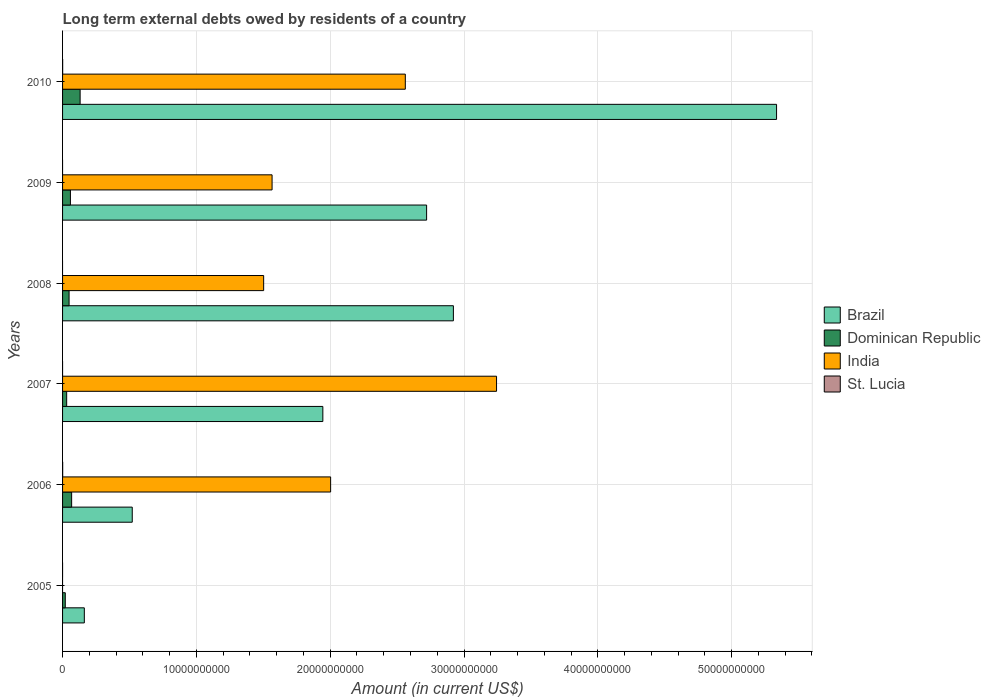How many different coloured bars are there?
Your response must be concise. 4. Are the number of bars per tick equal to the number of legend labels?
Provide a short and direct response. No. Are the number of bars on each tick of the Y-axis equal?
Make the answer very short. No. How many bars are there on the 6th tick from the top?
Provide a short and direct response. 2. What is the amount of long-term external debts owed by residents in Dominican Republic in 2006?
Provide a succinct answer. 6.78e+08. Across all years, what is the maximum amount of long-term external debts owed by residents in Brazil?
Give a very brief answer. 5.34e+1. Across all years, what is the minimum amount of long-term external debts owed by residents in India?
Offer a very short reply. 0. In which year was the amount of long-term external debts owed by residents in St. Lucia maximum?
Your answer should be compact. 2006. What is the total amount of long-term external debts owed by residents in India in the graph?
Provide a succinct answer. 1.09e+11. What is the difference between the amount of long-term external debts owed by residents in Brazil in 2006 and that in 2008?
Keep it short and to the point. -2.40e+1. What is the difference between the amount of long-term external debts owed by residents in India in 2009 and the amount of long-term external debts owed by residents in Brazil in 2008?
Offer a very short reply. -1.35e+1. What is the average amount of long-term external debts owed by residents in Brazil per year?
Make the answer very short. 2.27e+1. In the year 2010, what is the difference between the amount of long-term external debts owed by residents in India and amount of long-term external debts owed by residents in St. Lucia?
Your answer should be very brief. 2.56e+1. In how many years, is the amount of long-term external debts owed by residents in Dominican Republic greater than 40000000000 US$?
Your response must be concise. 0. What is the ratio of the amount of long-term external debts owed by residents in Brazil in 2007 to that in 2009?
Make the answer very short. 0.71. Is the amount of long-term external debts owed by residents in Brazil in 2009 less than that in 2010?
Provide a short and direct response. Yes. What is the difference between the highest and the second highest amount of long-term external debts owed by residents in Brazil?
Make the answer very short. 2.41e+1. What is the difference between the highest and the lowest amount of long-term external debts owed by residents in India?
Give a very brief answer. 3.24e+1. Is the sum of the amount of long-term external debts owed by residents in Dominican Republic in 2009 and 2010 greater than the maximum amount of long-term external debts owed by residents in Brazil across all years?
Keep it short and to the point. No. Is it the case that in every year, the sum of the amount of long-term external debts owed by residents in St. Lucia and amount of long-term external debts owed by residents in India is greater than the amount of long-term external debts owed by residents in Dominican Republic?
Your answer should be compact. No. How many bars are there?
Offer a very short reply. 19. How many years are there in the graph?
Keep it short and to the point. 6. What is the difference between two consecutive major ticks on the X-axis?
Offer a terse response. 1.00e+1. Are the values on the major ticks of X-axis written in scientific E-notation?
Provide a succinct answer. No. Does the graph contain grids?
Give a very brief answer. Yes. How many legend labels are there?
Ensure brevity in your answer.  4. What is the title of the graph?
Ensure brevity in your answer.  Long term external debts owed by residents of a country. Does "Kuwait" appear as one of the legend labels in the graph?
Your answer should be very brief. No. What is the Amount (in current US$) in Brazil in 2005?
Make the answer very short. 1.63e+09. What is the Amount (in current US$) of Dominican Republic in 2005?
Offer a terse response. 2.03e+08. What is the Amount (in current US$) in St. Lucia in 2005?
Provide a short and direct response. 0. What is the Amount (in current US$) of Brazil in 2006?
Your answer should be compact. 5.21e+09. What is the Amount (in current US$) of Dominican Republic in 2006?
Your response must be concise. 6.78e+08. What is the Amount (in current US$) of India in 2006?
Ensure brevity in your answer.  2.00e+1. What is the Amount (in current US$) in St. Lucia in 2006?
Provide a succinct answer. 8.48e+06. What is the Amount (in current US$) in Brazil in 2007?
Provide a succinct answer. 1.94e+1. What is the Amount (in current US$) of Dominican Republic in 2007?
Provide a succinct answer. 3.07e+08. What is the Amount (in current US$) of India in 2007?
Provide a succinct answer. 3.24e+1. What is the Amount (in current US$) of St. Lucia in 2007?
Your answer should be compact. 0. What is the Amount (in current US$) in Brazil in 2008?
Provide a short and direct response. 2.92e+1. What is the Amount (in current US$) of Dominican Republic in 2008?
Keep it short and to the point. 4.87e+08. What is the Amount (in current US$) in India in 2008?
Keep it short and to the point. 1.50e+1. What is the Amount (in current US$) of Brazil in 2009?
Your answer should be compact. 2.72e+1. What is the Amount (in current US$) in Dominican Republic in 2009?
Give a very brief answer. 5.87e+08. What is the Amount (in current US$) of India in 2009?
Offer a terse response. 1.57e+1. What is the Amount (in current US$) in Brazil in 2010?
Offer a terse response. 5.34e+1. What is the Amount (in current US$) of Dominican Republic in 2010?
Keep it short and to the point. 1.31e+09. What is the Amount (in current US$) of India in 2010?
Give a very brief answer. 2.56e+1. What is the Amount (in current US$) in St. Lucia in 2010?
Provide a succinct answer. 6.51e+06. Across all years, what is the maximum Amount (in current US$) in Brazil?
Your response must be concise. 5.34e+1. Across all years, what is the maximum Amount (in current US$) in Dominican Republic?
Ensure brevity in your answer.  1.31e+09. Across all years, what is the maximum Amount (in current US$) in India?
Your answer should be very brief. 3.24e+1. Across all years, what is the maximum Amount (in current US$) in St. Lucia?
Your response must be concise. 8.48e+06. Across all years, what is the minimum Amount (in current US$) in Brazil?
Your answer should be very brief. 1.63e+09. Across all years, what is the minimum Amount (in current US$) in Dominican Republic?
Your answer should be very brief. 2.03e+08. Across all years, what is the minimum Amount (in current US$) in India?
Make the answer very short. 0. Across all years, what is the minimum Amount (in current US$) of St. Lucia?
Provide a short and direct response. 0. What is the total Amount (in current US$) in Brazil in the graph?
Make the answer very short. 1.36e+11. What is the total Amount (in current US$) in Dominican Republic in the graph?
Provide a short and direct response. 3.57e+09. What is the total Amount (in current US$) of India in the graph?
Give a very brief answer. 1.09e+11. What is the total Amount (in current US$) of St. Lucia in the graph?
Provide a short and direct response. 1.50e+07. What is the difference between the Amount (in current US$) in Brazil in 2005 and that in 2006?
Make the answer very short. -3.58e+09. What is the difference between the Amount (in current US$) in Dominican Republic in 2005 and that in 2006?
Give a very brief answer. -4.75e+08. What is the difference between the Amount (in current US$) in Brazil in 2005 and that in 2007?
Provide a short and direct response. -1.78e+1. What is the difference between the Amount (in current US$) in Dominican Republic in 2005 and that in 2007?
Your response must be concise. -1.04e+08. What is the difference between the Amount (in current US$) of Brazil in 2005 and that in 2008?
Your answer should be compact. -2.76e+1. What is the difference between the Amount (in current US$) of Dominican Republic in 2005 and that in 2008?
Offer a very short reply. -2.84e+08. What is the difference between the Amount (in current US$) in Brazil in 2005 and that in 2009?
Give a very brief answer. -2.56e+1. What is the difference between the Amount (in current US$) in Dominican Republic in 2005 and that in 2009?
Your answer should be compact. -3.84e+08. What is the difference between the Amount (in current US$) in Brazil in 2005 and that in 2010?
Give a very brief answer. -5.17e+1. What is the difference between the Amount (in current US$) of Dominican Republic in 2005 and that in 2010?
Your response must be concise. -1.11e+09. What is the difference between the Amount (in current US$) in Brazil in 2006 and that in 2007?
Give a very brief answer. -1.42e+1. What is the difference between the Amount (in current US$) of Dominican Republic in 2006 and that in 2007?
Keep it short and to the point. 3.71e+08. What is the difference between the Amount (in current US$) of India in 2006 and that in 2007?
Keep it short and to the point. -1.24e+1. What is the difference between the Amount (in current US$) in Brazil in 2006 and that in 2008?
Ensure brevity in your answer.  -2.40e+1. What is the difference between the Amount (in current US$) in Dominican Republic in 2006 and that in 2008?
Your response must be concise. 1.91e+08. What is the difference between the Amount (in current US$) of India in 2006 and that in 2008?
Your response must be concise. 5.00e+09. What is the difference between the Amount (in current US$) of Brazil in 2006 and that in 2009?
Give a very brief answer. -2.20e+1. What is the difference between the Amount (in current US$) of Dominican Republic in 2006 and that in 2009?
Ensure brevity in your answer.  9.05e+07. What is the difference between the Amount (in current US$) of India in 2006 and that in 2009?
Make the answer very short. 4.38e+09. What is the difference between the Amount (in current US$) in Brazil in 2006 and that in 2010?
Provide a succinct answer. -4.81e+1. What is the difference between the Amount (in current US$) of Dominican Republic in 2006 and that in 2010?
Your response must be concise. -6.35e+08. What is the difference between the Amount (in current US$) in India in 2006 and that in 2010?
Your response must be concise. -5.58e+09. What is the difference between the Amount (in current US$) of St. Lucia in 2006 and that in 2010?
Offer a terse response. 1.97e+06. What is the difference between the Amount (in current US$) in Brazil in 2007 and that in 2008?
Ensure brevity in your answer.  -9.76e+09. What is the difference between the Amount (in current US$) in Dominican Republic in 2007 and that in 2008?
Your answer should be compact. -1.80e+08. What is the difference between the Amount (in current US$) of India in 2007 and that in 2008?
Ensure brevity in your answer.  1.74e+1. What is the difference between the Amount (in current US$) in Brazil in 2007 and that in 2009?
Your response must be concise. -7.75e+09. What is the difference between the Amount (in current US$) of Dominican Republic in 2007 and that in 2009?
Your answer should be very brief. -2.80e+08. What is the difference between the Amount (in current US$) in India in 2007 and that in 2009?
Your response must be concise. 1.68e+1. What is the difference between the Amount (in current US$) in Brazil in 2007 and that in 2010?
Your response must be concise. -3.39e+1. What is the difference between the Amount (in current US$) in Dominican Republic in 2007 and that in 2010?
Ensure brevity in your answer.  -1.01e+09. What is the difference between the Amount (in current US$) of India in 2007 and that in 2010?
Make the answer very short. 6.82e+09. What is the difference between the Amount (in current US$) in Brazil in 2008 and that in 2009?
Offer a terse response. 2.00e+09. What is the difference between the Amount (in current US$) of Dominican Republic in 2008 and that in 2009?
Offer a very short reply. -1.00e+08. What is the difference between the Amount (in current US$) in India in 2008 and that in 2009?
Keep it short and to the point. -6.29e+08. What is the difference between the Amount (in current US$) of Brazil in 2008 and that in 2010?
Your response must be concise. -2.41e+1. What is the difference between the Amount (in current US$) in Dominican Republic in 2008 and that in 2010?
Keep it short and to the point. -8.25e+08. What is the difference between the Amount (in current US$) of India in 2008 and that in 2010?
Offer a very short reply. -1.06e+1. What is the difference between the Amount (in current US$) in Brazil in 2009 and that in 2010?
Keep it short and to the point. -2.61e+1. What is the difference between the Amount (in current US$) of Dominican Republic in 2009 and that in 2010?
Offer a terse response. -7.25e+08. What is the difference between the Amount (in current US$) of India in 2009 and that in 2010?
Give a very brief answer. -9.96e+09. What is the difference between the Amount (in current US$) of Brazil in 2005 and the Amount (in current US$) of Dominican Republic in 2006?
Make the answer very short. 9.49e+08. What is the difference between the Amount (in current US$) of Brazil in 2005 and the Amount (in current US$) of India in 2006?
Your answer should be compact. -1.84e+1. What is the difference between the Amount (in current US$) of Brazil in 2005 and the Amount (in current US$) of St. Lucia in 2006?
Give a very brief answer. 1.62e+09. What is the difference between the Amount (in current US$) of Dominican Republic in 2005 and the Amount (in current US$) of India in 2006?
Ensure brevity in your answer.  -1.98e+1. What is the difference between the Amount (in current US$) in Dominican Republic in 2005 and the Amount (in current US$) in St. Lucia in 2006?
Keep it short and to the point. 1.95e+08. What is the difference between the Amount (in current US$) in Brazil in 2005 and the Amount (in current US$) in Dominican Republic in 2007?
Keep it short and to the point. 1.32e+09. What is the difference between the Amount (in current US$) in Brazil in 2005 and the Amount (in current US$) in India in 2007?
Provide a short and direct response. -3.08e+1. What is the difference between the Amount (in current US$) in Dominican Republic in 2005 and the Amount (in current US$) in India in 2007?
Your response must be concise. -3.22e+1. What is the difference between the Amount (in current US$) of Brazil in 2005 and the Amount (in current US$) of Dominican Republic in 2008?
Keep it short and to the point. 1.14e+09. What is the difference between the Amount (in current US$) in Brazil in 2005 and the Amount (in current US$) in India in 2008?
Offer a very short reply. -1.34e+1. What is the difference between the Amount (in current US$) of Dominican Republic in 2005 and the Amount (in current US$) of India in 2008?
Your answer should be compact. -1.48e+1. What is the difference between the Amount (in current US$) of Brazil in 2005 and the Amount (in current US$) of Dominican Republic in 2009?
Ensure brevity in your answer.  1.04e+09. What is the difference between the Amount (in current US$) in Brazil in 2005 and the Amount (in current US$) in India in 2009?
Give a very brief answer. -1.40e+1. What is the difference between the Amount (in current US$) in Dominican Republic in 2005 and the Amount (in current US$) in India in 2009?
Ensure brevity in your answer.  -1.55e+1. What is the difference between the Amount (in current US$) of Brazil in 2005 and the Amount (in current US$) of Dominican Republic in 2010?
Ensure brevity in your answer.  3.14e+08. What is the difference between the Amount (in current US$) in Brazil in 2005 and the Amount (in current US$) in India in 2010?
Offer a very short reply. -2.40e+1. What is the difference between the Amount (in current US$) of Brazil in 2005 and the Amount (in current US$) of St. Lucia in 2010?
Provide a succinct answer. 1.62e+09. What is the difference between the Amount (in current US$) of Dominican Republic in 2005 and the Amount (in current US$) of India in 2010?
Offer a terse response. -2.54e+1. What is the difference between the Amount (in current US$) of Dominican Republic in 2005 and the Amount (in current US$) of St. Lucia in 2010?
Your answer should be very brief. 1.97e+08. What is the difference between the Amount (in current US$) of Brazil in 2006 and the Amount (in current US$) of Dominican Republic in 2007?
Offer a very short reply. 4.90e+09. What is the difference between the Amount (in current US$) in Brazil in 2006 and the Amount (in current US$) in India in 2007?
Provide a short and direct response. -2.72e+1. What is the difference between the Amount (in current US$) in Dominican Republic in 2006 and the Amount (in current US$) in India in 2007?
Offer a terse response. -3.18e+1. What is the difference between the Amount (in current US$) of Brazil in 2006 and the Amount (in current US$) of Dominican Republic in 2008?
Offer a very short reply. 4.72e+09. What is the difference between the Amount (in current US$) of Brazil in 2006 and the Amount (in current US$) of India in 2008?
Your answer should be very brief. -9.82e+09. What is the difference between the Amount (in current US$) of Dominican Republic in 2006 and the Amount (in current US$) of India in 2008?
Provide a succinct answer. -1.43e+1. What is the difference between the Amount (in current US$) in Brazil in 2006 and the Amount (in current US$) in Dominican Republic in 2009?
Provide a succinct answer. 4.62e+09. What is the difference between the Amount (in current US$) of Brazil in 2006 and the Amount (in current US$) of India in 2009?
Offer a terse response. -1.04e+1. What is the difference between the Amount (in current US$) of Dominican Republic in 2006 and the Amount (in current US$) of India in 2009?
Offer a very short reply. -1.50e+1. What is the difference between the Amount (in current US$) in Brazil in 2006 and the Amount (in current US$) in Dominican Republic in 2010?
Offer a very short reply. 3.89e+09. What is the difference between the Amount (in current US$) in Brazil in 2006 and the Amount (in current US$) in India in 2010?
Offer a terse response. -2.04e+1. What is the difference between the Amount (in current US$) in Brazil in 2006 and the Amount (in current US$) in St. Lucia in 2010?
Your answer should be compact. 5.20e+09. What is the difference between the Amount (in current US$) in Dominican Republic in 2006 and the Amount (in current US$) in India in 2010?
Ensure brevity in your answer.  -2.49e+1. What is the difference between the Amount (in current US$) in Dominican Republic in 2006 and the Amount (in current US$) in St. Lucia in 2010?
Give a very brief answer. 6.71e+08. What is the difference between the Amount (in current US$) of India in 2006 and the Amount (in current US$) of St. Lucia in 2010?
Keep it short and to the point. 2.00e+1. What is the difference between the Amount (in current US$) of Brazil in 2007 and the Amount (in current US$) of Dominican Republic in 2008?
Your answer should be compact. 1.90e+1. What is the difference between the Amount (in current US$) in Brazil in 2007 and the Amount (in current US$) in India in 2008?
Your response must be concise. 4.42e+09. What is the difference between the Amount (in current US$) of Dominican Republic in 2007 and the Amount (in current US$) of India in 2008?
Your response must be concise. -1.47e+1. What is the difference between the Amount (in current US$) in Brazil in 2007 and the Amount (in current US$) in Dominican Republic in 2009?
Ensure brevity in your answer.  1.89e+1. What is the difference between the Amount (in current US$) of Brazil in 2007 and the Amount (in current US$) of India in 2009?
Make the answer very short. 3.79e+09. What is the difference between the Amount (in current US$) in Dominican Republic in 2007 and the Amount (in current US$) in India in 2009?
Ensure brevity in your answer.  -1.53e+1. What is the difference between the Amount (in current US$) of Brazil in 2007 and the Amount (in current US$) of Dominican Republic in 2010?
Your answer should be compact. 1.81e+1. What is the difference between the Amount (in current US$) of Brazil in 2007 and the Amount (in current US$) of India in 2010?
Offer a terse response. -6.16e+09. What is the difference between the Amount (in current US$) of Brazil in 2007 and the Amount (in current US$) of St. Lucia in 2010?
Ensure brevity in your answer.  1.94e+1. What is the difference between the Amount (in current US$) of Dominican Republic in 2007 and the Amount (in current US$) of India in 2010?
Provide a succinct answer. -2.53e+1. What is the difference between the Amount (in current US$) of Dominican Republic in 2007 and the Amount (in current US$) of St. Lucia in 2010?
Give a very brief answer. 3.01e+08. What is the difference between the Amount (in current US$) of India in 2007 and the Amount (in current US$) of St. Lucia in 2010?
Offer a terse response. 3.24e+1. What is the difference between the Amount (in current US$) of Brazil in 2008 and the Amount (in current US$) of Dominican Republic in 2009?
Your answer should be very brief. 2.86e+1. What is the difference between the Amount (in current US$) in Brazil in 2008 and the Amount (in current US$) in India in 2009?
Keep it short and to the point. 1.35e+1. What is the difference between the Amount (in current US$) in Dominican Republic in 2008 and the Amount (in current US$) in India in 2009?
Keep it short and to the point. -1.52e+1. What is the difference between the Amount (in current US$) of Brazil in 2008 and the Amount (in current US$) of Dominican Republic in 2010?
Keep it short and to the point. 2.79e+1. What is the difference between the Amount (in current US$) in Brazil in 2008 and the Amount (in current US$) in India in 2010?
Give a very brief answer. 3.59e+09. What is the difference between the Amount (in current US$) in Brazil in 2008 and the Amount (in current US$) in St. Lucia in 2010?
Your answer should be very brief. 2.92e+1. What is the difference between the Amount (in current US$) in Dominican Republic in 2008 and the Amount (in current US$) in India in 2010?
Your answer should be compact. -2.51e+1. What is the difference between the Amount (in current US$) in Dominican Republic in 2008 and the Amount (in current US$) in St. Lucia in 2010?
Your answer should be very brief. 4.81e+08. What is the difference between the Amount (in current US$) of India in 2008 and the Amount (in current US$) of St. Lucia in 2010?
Provide a succinct answer. 1.50e+1. What is the difference between the Amount (in current US$) in Brazil in 2009 and the Amount (in current US$) in Dominican Republic in 2010?
Your answer should be very brief. 2.59e+1. What is the difference between the Amount (in current US$) in Brazil in 2009 and the Amount (in current US$) in India in 2010?
Give a very brief answer. 1.59e+09. What is the difference between the Amount (in current US$) of Brazil in 2009 and the Amount (in current US$) of St. Lucia in 2010?
Your answer should be compact. 2.72e+1. What is the difference between the Amount (in current US$) of Dominican Republic in 2009 and the Amount (in current US$) of India in 2010?
Make the answer very short. -2.50e+1. What is the difference between the Amount (in current US$) of Dominican Republic in 2009 and the Amount (in current US$) of St. Lucia in 2010?
Offer a terse response. 5.81e+08. What is the difference between the Amount (in current US$) in India in 2009 and the Amount (in current US$) in St. Lucia in 2010?
Give a very brief answer. 1.56e+1. What is the average Amount (in current US$) of Brazil per year?
Offer a terse response. 2.27e+1. What is the average Amount (in current US$) in Dominican Republic per year?
Ensure brevity in your answer.  5.96e+08. What is the average Amount (in current US$) in India per year?
Make the answer very short. 1.81e+1. What is the average Amount (in current US$) in St. Lucia per year?
Offer a terse response. 2.50e+06. In the year 2005, what is the difference between the Amount (in current US$) of Brazil and Amount (in current US$) of Dominican Republic?
Provide a succinct answer. 1.42e+09. In the year 2006, what is the difference between the Amount (in current US$) in Brazil and Amount (in current US$) in Dominican Republic?
Ensure brevity in your answer.  4.53e+09. In the year 2006, what is the difference between the Amount (in current US$) of Brazil and Amount (in current US$) of India?
Give a very brief answer. -1.48e+1. In the year 2006, what is the difference between the Amount (in current US$) in Brazil and Amount (in current US$) in St. Lucia?
Give a very brief answer. 5.20e+09. In the year 2006, what is the difference between the Amount (in current US$) in Dominican Republic and Amount (in current US$) in India?
Your answer should be compact. -1.94e+1. In the year 2006, what is the difference between the Amount (in current US$) of Dominican Republic and Amount (in current US$) of St. Lucia?
Offer a very short reply. 6.69e+08. In the year 2006, what is the difference between the Amount (in current US$) in India and Amount (in current US$) in St. Lucia?
Keep it short and to the point. 2.00e+1. In the year 2007, what is the difference between the Amount (in current US$) in Brazil and Amount (in current US$) in Dominican Republic?
Your answer should be very brief. 1.91e+1. In the year 2007, what is the difference between the Amount (in current US$) in Brazil and Amount (in current US$) in India?
Make the answer very short. -1.30e+1. In the year 2007, what is the difference between the Amount (in current US$) in Dominican Republic and Amount (in current US$) in India?
Ensure brevity in your answer.  -3.21e+1. In the year 2008, what is the difference between the Amount (in current US$) in Brazil and Amount (in current US$) in Dominican Republic?
Your answer should be very brief. 2.87e+1. In the year 2008, what is the difference between the Amount (in current US$) in Brazil and Amount (in current US$) in India?
Your answer should be very brief. 1.42e+1. In the year 2008, what is the difference between the Amount (in current US$) in Dominican Republic and Amount (in current US$) in India?
Your answer should be very brief. -1.45e+1. In the year 2009, what is the difference between the Amount (in current US$) in Brazil and Amount (in current US$) in Dominican Republic?
Give a very brief answer. 2.66e+1. In the year 2009, what is the difference between the Amount (in current US$) in Brazil and Amount (in current US$) in India?
Make the answer very short. 1.15e+1. In the year 2009, what is the difference between the Amount (in current US$) in Dominican Republic and Amount (in current US$) in India?
Provide a short and direct response. -1.51e+1. In the year 2010, what is the difference between the Amount (in current US$) of Brazil and Amount (in current US$) of Dominican Republic?
Keep it short and to the point. 5.20e+1. In the year 2010, what is the difference between the Amount (in current US$) of Brazil and Amount (in current US$) of India?
Provide a short and direct response. 2.77e+1. In the year 2010, what is the difference between the Amount (in current US$) of Brazil and Amount (in current US$) of St. Lucia?
Provide a short and direct response. 5.33e+1. In the year 2010, what is the difference between the Amount (in current US$) in Dominican Republic and Amount (in current US$) in India?
Provide a short and direct response. -2.43e+1. In the year 2010, what is the difference between the Amount (in current US$) of Dominican Republic and Amount (in current US$) of St. Lucia?
Your answer should be very brief. 1.31e+09. In the year 2010, what is the difference between the Amount (in current US$) in India and Amount (in current US$) in St. Lucia?
Your answer should be compact. 2.56e+1. What is the ratio of the Amount (in current US$) in Brazil in 2005 to that in 2006?
Provide a succinct answer. 0.31. What is the ratio of the Amount (in current US$) of Dominican Republic in 2005 to that in 2006?
Give a very brief answer. 0.3. What is the ratio of the Amount (in current US$) of Brazil in 2005 to that in 2007?
Make the answer very short. 0.08. What is the ratio of the Amount (in current US$) in Dominican Republic in 2005 to that in 2007?
Give a very brief answer. 0.66. What is the ratio of the Amount (in current US$) in Brazil in 2005 to that in 2008?
Give a very brief answer. 0.06. What is the ratio of the Amount (in current US$) of Dominican Republic in 2005 to that in 2008?
Give a very brief answer. 0.42. What is the ratio of the Amount (in current US$) in Brazil in 2005 to that in 2009?
Offer a very short reply. 0.06. What is the ratio of the Amount (in current US$) of Dominican Republic in 2005 to that in 2009?
Your answer should be very brief. 0.35. What is the ratio of the Amount (in current US$) of Brazil in 2005 to that in 2010?
Keep it short and to the point. 0.03. What is the ratio of the Amount (in current US$) of Dominican Republic in 2005 to that in 2010?
Provide a succinct answer. 0.15. What is the ratio of the Amount (in current US$) of Brazil in 2006 to that in 2007?
Offer a terse response. 0.27. What is the ratio of the Amount (in current US$) of Dominican Republic in 2006 to that in 2007?
Give a very brief answer. 2.21. What is the ratio of the Amount (in current US$) of India in 2006 to that in 2007?
Offer a very short reply. 0.62. What is the ratio of the Amount (in current US$) of Brazil in 2006 to that in 2008?
Offer a very short reply. 0.18. What is the ratio of the Amount (in current US$) of Dominican Republic in 2006 to that in 2008?
Offer a very short reply. 1.39. What is the ratio of the Amount (in current US$) of India in 2006 to that in 2008?
Provide a short and direct response. 1.33. What is the ratio of the Amount (in current US$) in Brazil in 2006 to that in 2009?
Provide a succinct answer. 0.19. What is the ratio of the Amount (in current US$) in Dominican Republic in 2006 to that in 2009?
Offer a terse response. 1.15. What is the ratio of the Amount (in current US$) in India in 2006 to that in 2009?
Your answer should be compact. 1.28. What is the ratio of the Amount (in current US$) in Brazil in 2006 to that in 2010?
Keep it short and to the point. 0.1. What is the ratio of the Amount (in current US$) in Dominican Republic in 2006 to that in 2010?
Provide a short and direct response. 0.52. What is the ratio of the Amount (in current US$) of India in 2006 to that in 2010?
Keep it short and to the point. 0.78. What is the ratio of the Amount (in current US$) in St. Lucia in 2006 to that in 2010?
Ensure brevity in your answer.  1.3. What is the ratio of the Amount (in current US$) in Brazil in 2007 to that in 2008?
Your answer should be very brief. 0.67. What is the ratio of the Amount (in current US$) in Dominican Republic in 2007 to that in 2008?
Provide a short and direct response. 0.63. What is the ratio of the Amount (in current US$) of India in 2007 to that in 2008?
Keep it short and to the point. 2.16. What is the ratio of the Amount (in current US$) of Brazil in 2007 to that in 2009?
Provide a succinct answer. 0.71. What is the ratio of the Amount (in current US$) in Dominican Republic in 2007 to that in 2009?
Give a very brief answer. 0.52. What is the ratio of the Amount (in current US$) in India in 2007 to that in 2009?
Make the answer very short. 2.07. What is the ratio of the Amount (in current US$) in Brazil in 2007 to that in 2010?
Your answer should be very brief. 0.36. What is the ratio of the Amount (in current US$) of Dominican Republic in 2007 to that in 2010?
Offer a terse response. 0.23. What is the ratio of the Amount (in current US$) in India in 2007 to that in 2010?
Your response must be concise. 1.27. What is the ratio of the Amount (in current US$) in Brazil in 2008 to that in 2009?
Provide a short and direct response. 1.07. What is the ratio of the Amount (in current US$) in Dominican Republic in 2008 to that in 2009?
Your answer should be compact. 0.83. What is the ratio of the Amount (in current US$) of India in 2008 to that in 2009?
Your answer should be compact. 0.96. What is the ratio of the Amount (in current US$) of Brazil in 2008 to that in 2010?
Offer a very short reply. 0.55. What is the ratio of the Amount (in current US$) in Dominican Republic in 2008 to that in 2010?
Provide a succinct answer. 0.37. What is the ratio of the Amount (in current US$) of India in 2008 to that in 2010?
Provide a succinct answer. 0.59. What is the ratio of the Amount (in current US$) of Brazil in 2009 to that in 2010?
Provide a succinct answer. 0.51. What is the ratio of the Amount (in current US$) in Dominican Republic in 2009 to that in 2010?
Offer a terse response. 0.45. What is the ratio of the Amount (in current US$) in India in 2009 to that in 2010?
Offer a terse response. 0.61. What is the difference between the highest and the second highest Amount (in current US$) in Brazil?
Provide a short and direct response. 2.41e+1. What is the difference between the highest and the second highest Amount (in current US$) of Dominican Republic?
Your answer should be compact. 6.35e+08. What is the difference between the highest and the second highest Amount (in current US$) of India?
Give a very brief answer. 6.82e+09. What is the difference between the highest and the lowest Amount (in current US$) in Brazil?
Offer a terse response. 5.17e+1. What is the difference between the highest and the lowest Amount (in current US$) of Dominican Republic?
Keep it short and to the point. 1.11e+09. What is the difference between the highest and the lowest Amount (in current US$) of India?
Make the answer very short. 3.24e+1. What is the difference between the highest and the lowest Amount (in current US$) in St. Lucia?
Keep it short and to the point. 8.48e+06. 